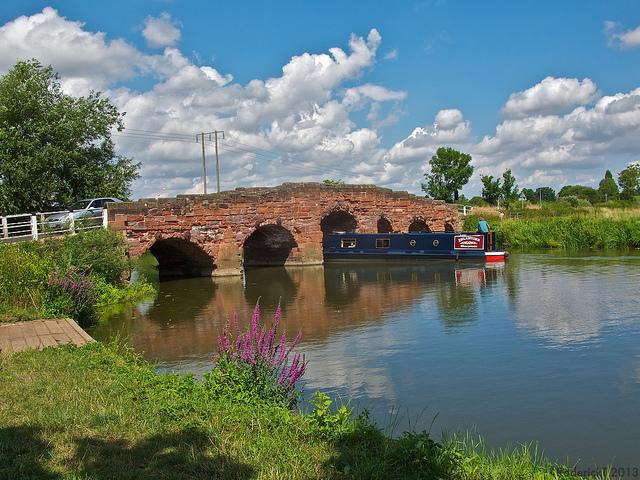Where is the boat going?

Choices:
A) over bridge
B) home
C) under bridge
D) up river under bridge 